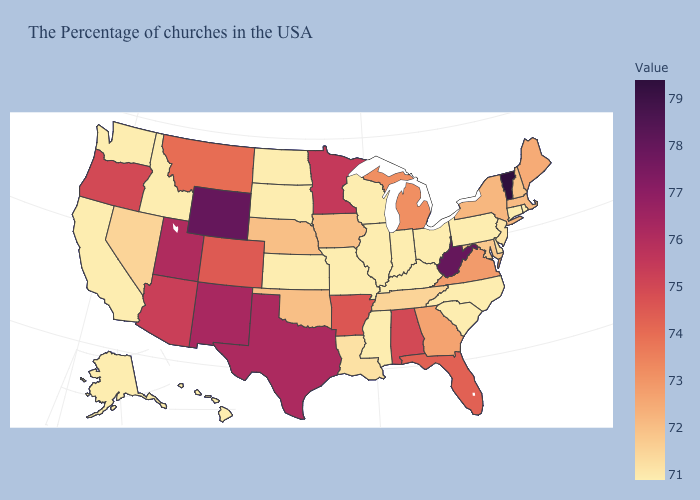Which states have the highest value in the USA?
Short answer required. Vermont. Does Michigan have a lower value than West Virginia?
Give a very brief answer. Yes. Which states have the lowest value in the West?
Give a very brief answer. Idaho, California, Washington, Alaska, Hawaii. 